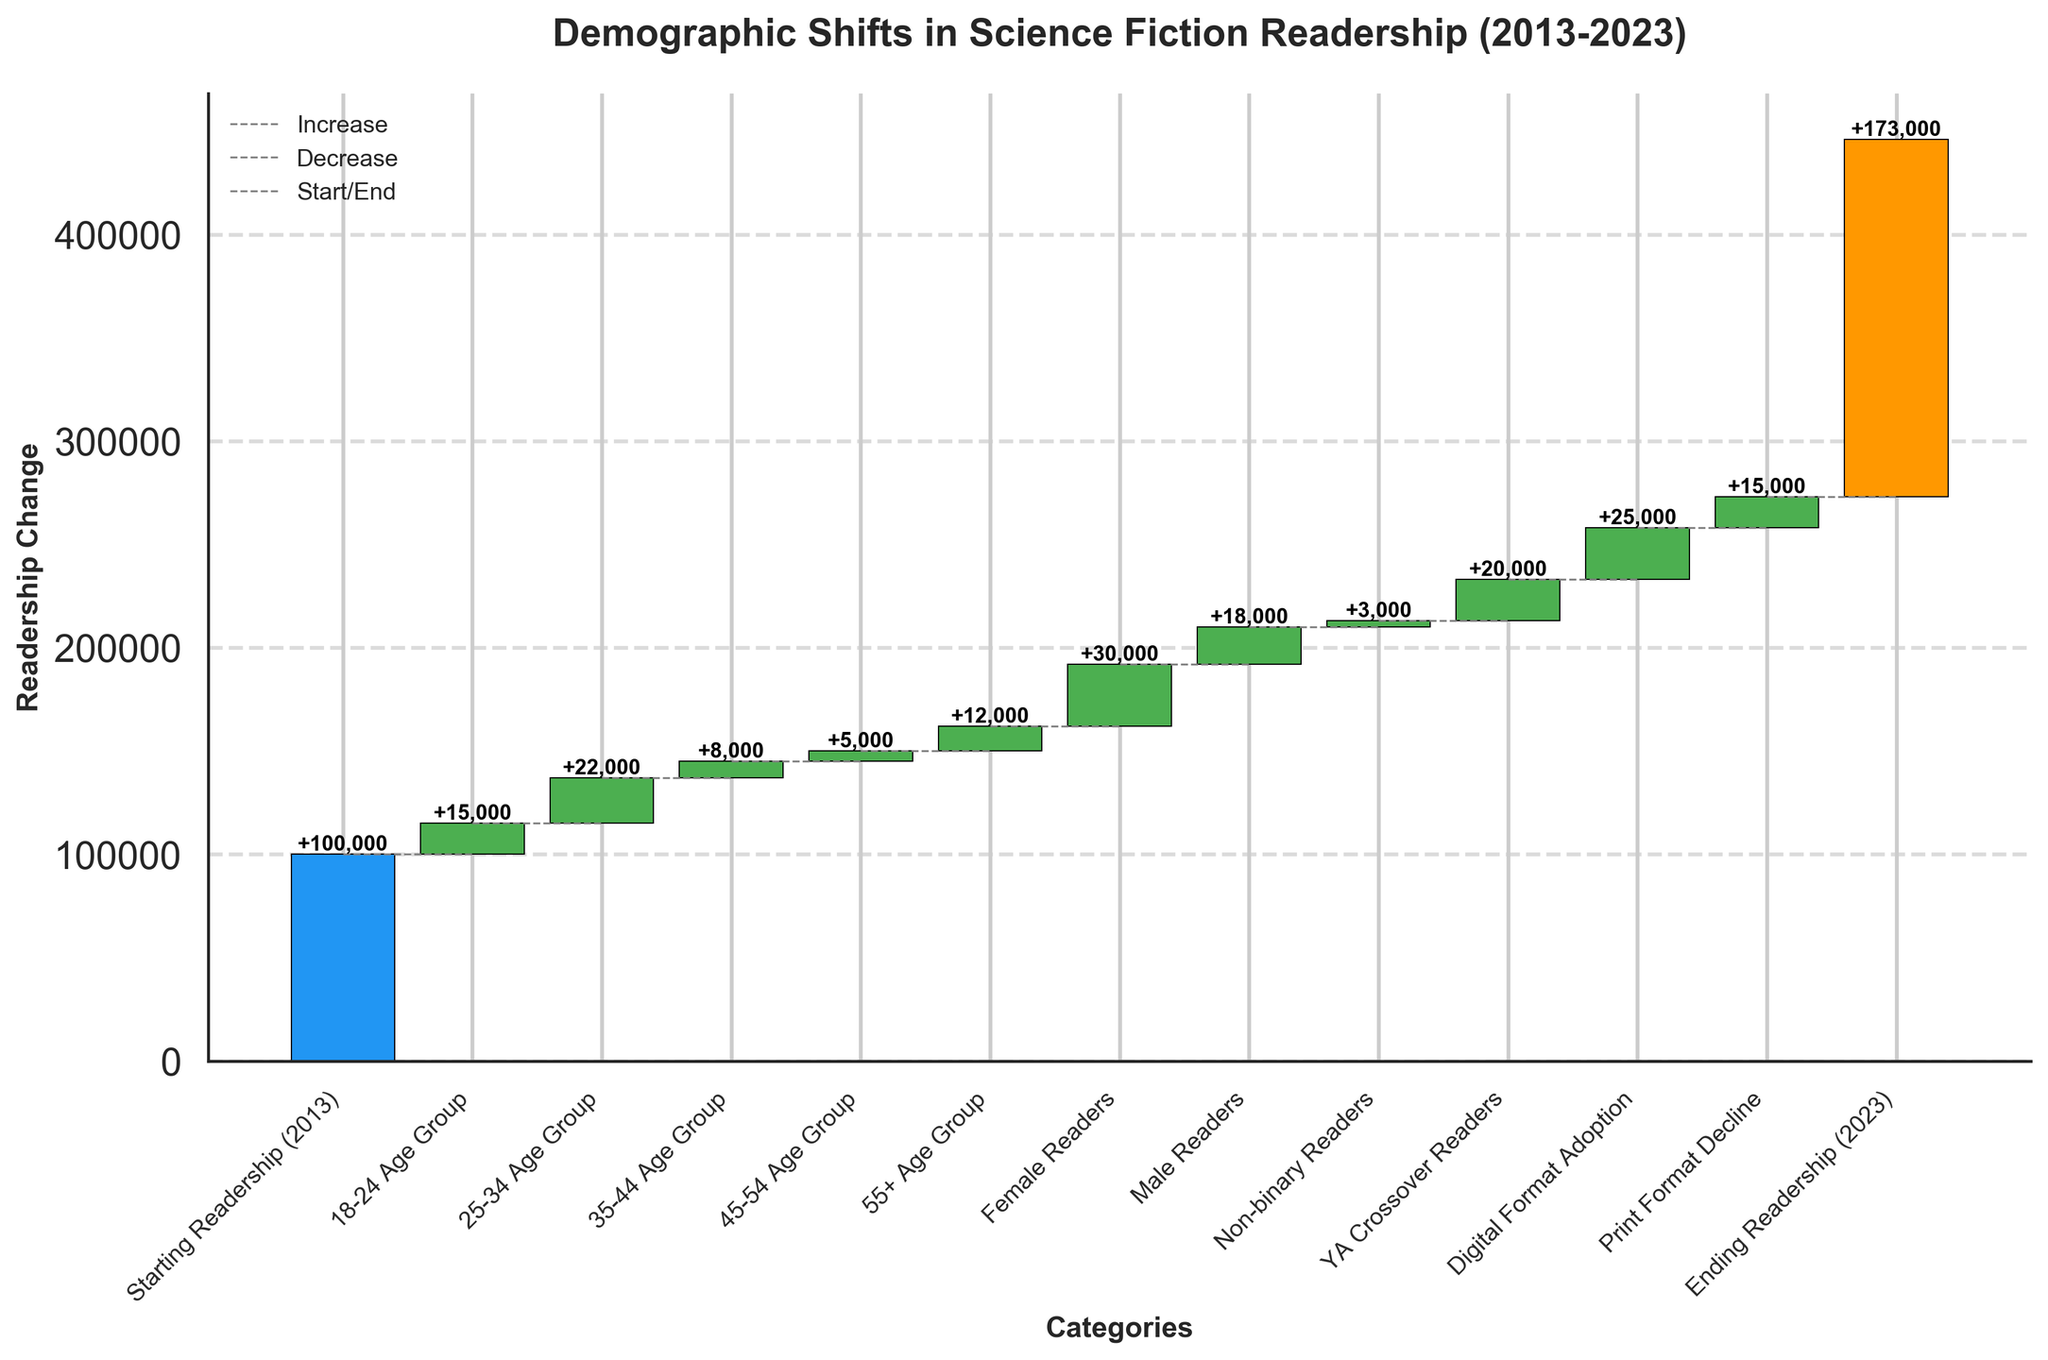What's the title of the chart? The title is prominently displayed at the top of the chart.
Answer: Demographic Shifts in Science Fiction Readership (2013-2023) What is the change in the 25-34 Age Group? The chart shows that the 25-34 Age Group has a positive change indicated by a green bar. The value can be read directly from the chart.
Answer: +22,000 What's the total change in readership due to demographic shifts by age group? To find the total change, sum the values for all age groups: 15,000 (18-24) + 22,000 (25-34) + 8,000 (35-44) - 5,000 (45-54) - 12,000 (55+).
Answer: +28,000 Which group saw the largest increase in readership? By comparing all the positive changes, the highest bar is for Digital Format Adoption.
Answer: Digital Format Adoption How did readership among male readers change? The value for male readers is displayed as a negative number on the chart, indicated by a red bar.
Answer: -18,000 What was the final readership number in 2023? The figure at the last category labeled 'Ending Readership (2023)' shows this value.
Answer: 173,000 How many groups showed a decrease in readership? By counting the bars that are marked in red: 45-54 Age Group, 55+ Age Group, Male Readers, and Print Format Decline.
Answer: 4 What's the combined effect of YA Crossover Readers and Digital Format Adoption? Add the values for YA Crossover Readers (+20,000) and Digital Format Adoption (+25,000).
Answer: +45,000 Compare the readership change between 35-44 Age Group and 45-54 Age Group. Which saw a greater change? By looking at the bars, the 35-44 Age Group has a positive change of +8,000 and the 45-54 Age Group has a negative change of -5,000.
Answer: 35-44 Age Group What is the net effect of format changes (Digital and Print)? Sum the value of Digital Format Adoption (+25,000) and Print Format Decline (-15,000).
Answer: +10,000 